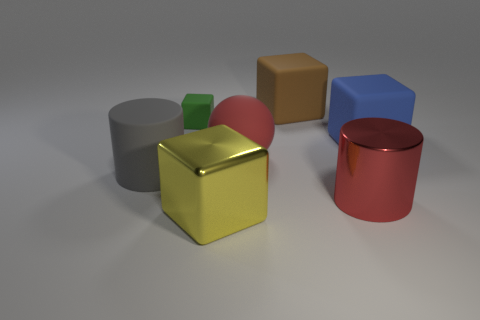Add 2 tiny green objects. How many objects exist? 9 Subtract all yellow metal cubes. How many cubes are left? 3 Subtract 1 cubes. How many cubes are left? 3 Subtract all brown cubes. How many cubes are left? 3 Subtract all cylinders. How many objects are left? 5 Subtract all red cubes. Subtract all yellow balls. How many cubes are left? 4 Subtract all gray cylinders. Subtract all big brown balls. How many objects are left? 6 Add 4 big yellow metallic blocks. How many big yellow metallic blocks are left? 5 Add 2 rubber blocks. How many rubber blocks exist? 5 Subtract 0 gray cubes. How many objects are left? 7 